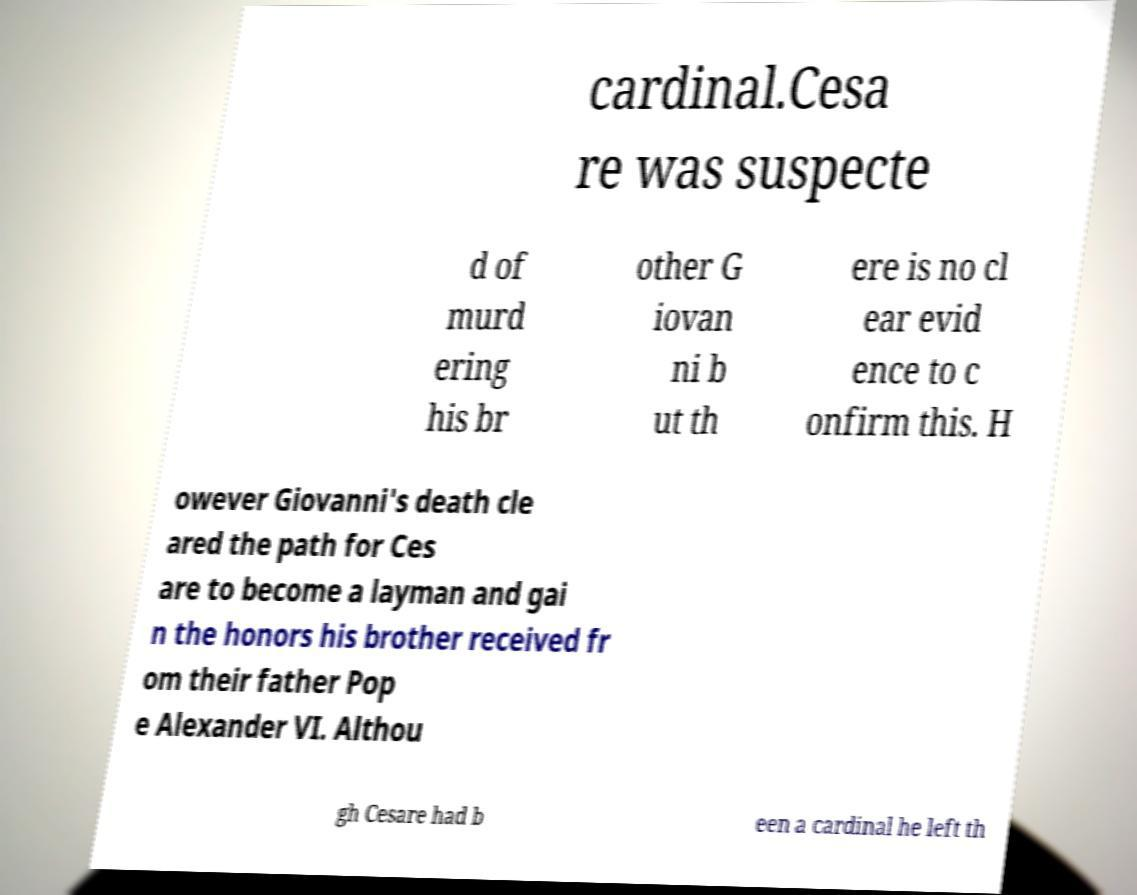I need the written content from this picture converted into text. Can you do that? cardinal.Cesa re was suspecte d of murd ering his br other G iovan ni b ut th ere is no cl ear evid ence to c onfirm this. H owever Giovanni's death cle ared the path for Ces are to become a layman and gai n the honors his brother received fr om their father Pop e Alexander VI. Althou gh Cesare had b een a cardinal he left th 